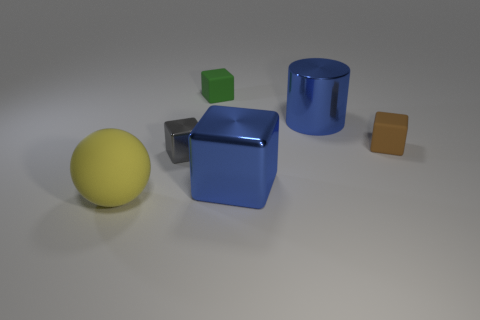What number of matte objects are in front of the large cylinder and right of the large yellow matte ball?
Make the answer very short. 1. The tiny shiny block is what color?
Your response must be concise. Gray. Are there any large purple blocks made of the same material as the brown cube?
Your response must be concise. No. There is a matte cube that is on the right side of the metal thing behind the brown cube; is there a tiny block in front of it?
Your answer should be compact. Yes. There is a small gray metallic object; are there any yellow balls in front of it?
Give a very brief answer. Yes. Is there a big matte object of the same color as the matte sphere?
Provide a succinct answer. No. What number of large objects are green matte objects or blue cylinders?
Your response must be concise. 1. Is the big blue object that is in front of the gray thing made of the same material as the small brown block?
Offer a very short reply. No. There is a large metal thing that is behind the gray metallic thing behind the large blue shiny object in front of the small brown thing; what shape is it?
Offer a very short reply. Cylinder. What number of cyan objects are large metallic objects or large metallic blocks?
Give a very brief answer. 0. 